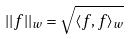<formula> <loc_0><loc_0><loc_500><loc_500>| | f | | _ { w } = \sqrt { \langle f , f \rangle _ { w } }</formula> 